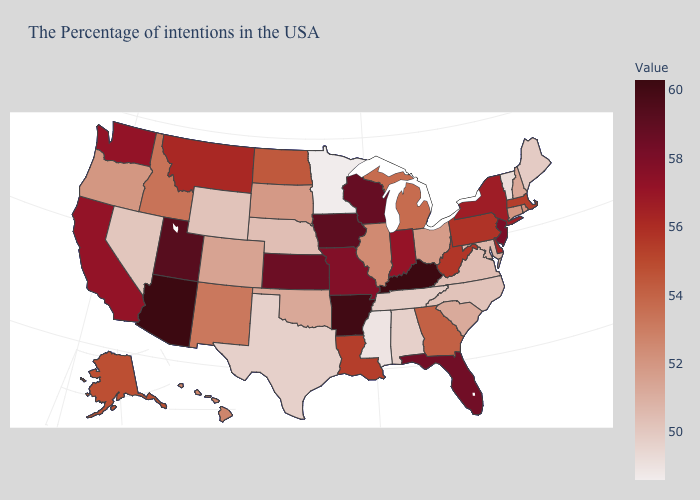Which states have the lowest value in the MidWest?
Be succinct. Minnesota. Which states have the lowest value in the USA?
Give a very brief answer. Minnesota. Among the states that border West Virginia , does Kentucky have the highest value?
Write a very short answer. Yes. Does Kentucky have the lowest value in the South?
Keep it brief. No. Which states have the highest value in the USA?
Be succinct. Kentucky, Arizona. Does the map have missing data?
Quick response, please. No. Is the legend a continuous bar?
Give a very brief answer. Yes. Among the states that border Georgia , does Tennessee have the lowest value?
Concise answer only. No. 